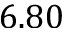Convert formula to latex. <formula><loc_0><loc_0><loc_500><loc_500>6 . 8 0</formula> 